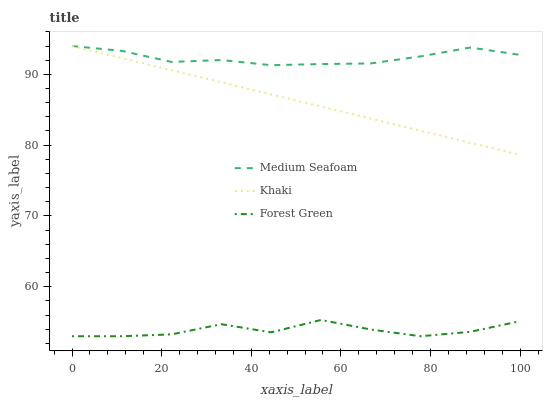Does Khaki have the minimum area under the curve?
Answer yes or no. No. Does Khaki have the maximum area under the curve?
Answer yes or no. No. Is Medium Seafoam the smoothest?
Answer yes or no. No. Is Medium Seafoam the roughest?
Answer yes or no. No. Does Khaki have the lowest value?
Answer yes or no. No. Is Forest Green less than Khaki?
Answer yes or no. Yes. Is Khaki greater than Forest Green?
Answer yes or no. Yes. Does Forest Green intersect Khaki?
Answer yes or no. No. 